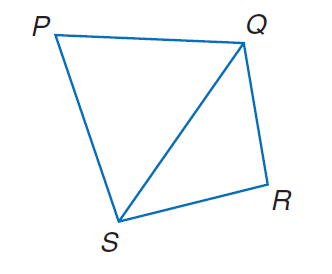Answer the mathemtical geometry problem and directly provide the correct option letter.
Question: In quadrilateral P Q R S, P Q = 721, Q R = 547, R S = 593, P S = 756, and m \angle P = 58. Find m \angle R.
Choices: A: 53.4 B: 67.4 C: 77.8 D: 87.6 C 